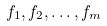Convert formula to latex. <formula><loc_0><loc_0><loc_500><loc_500>f _ { 1 } , f _ { 2 } , \dots , f _ { m }</formula> 